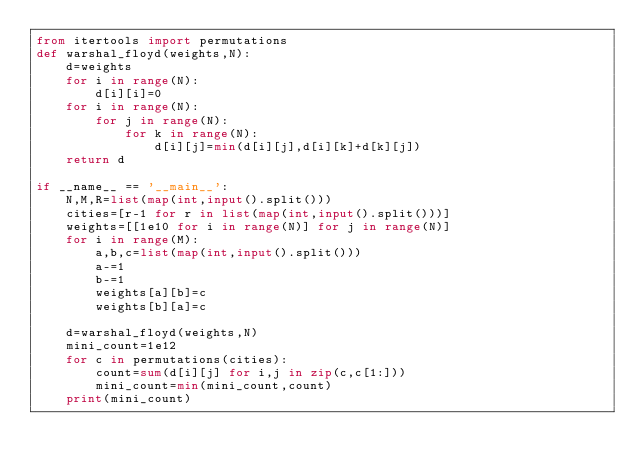<code> <loc_0><loc_0><loc_500><loc_500><_Python_>from itertools import permutations
def warshal_floyd(weights,N):
    d=weights
    for i in range(N):
        d[i][i]=0
    for i in range(N):
        for j in range(N):
            for k in range(N):
                d[i][j]=min(d[i][j],d[i][k]+d[k][j])
    return d

if __name__ == '__main__':
    N,M,R=list(map(int,input().split()))
    cities=[r-1 for r in list(map(int,input().split()))]
    weights=[[1e10 for i in range(N)] for j in range(N)]
    for i in range(M):
        a,b,c=list(map(int,input().split()))
        a-=1
        b-=1
        weights[a][b]=c
        weights[b][a]=c

    d=warshal_floyd(weights,N)
    mini_count=1e12
    for c in permutations(cities):
        count=sum(d[i][j] for i,j in zip(c,c[1:]))
        mini_count=min(mini_count,count)
    print(mini_count)
</code> 